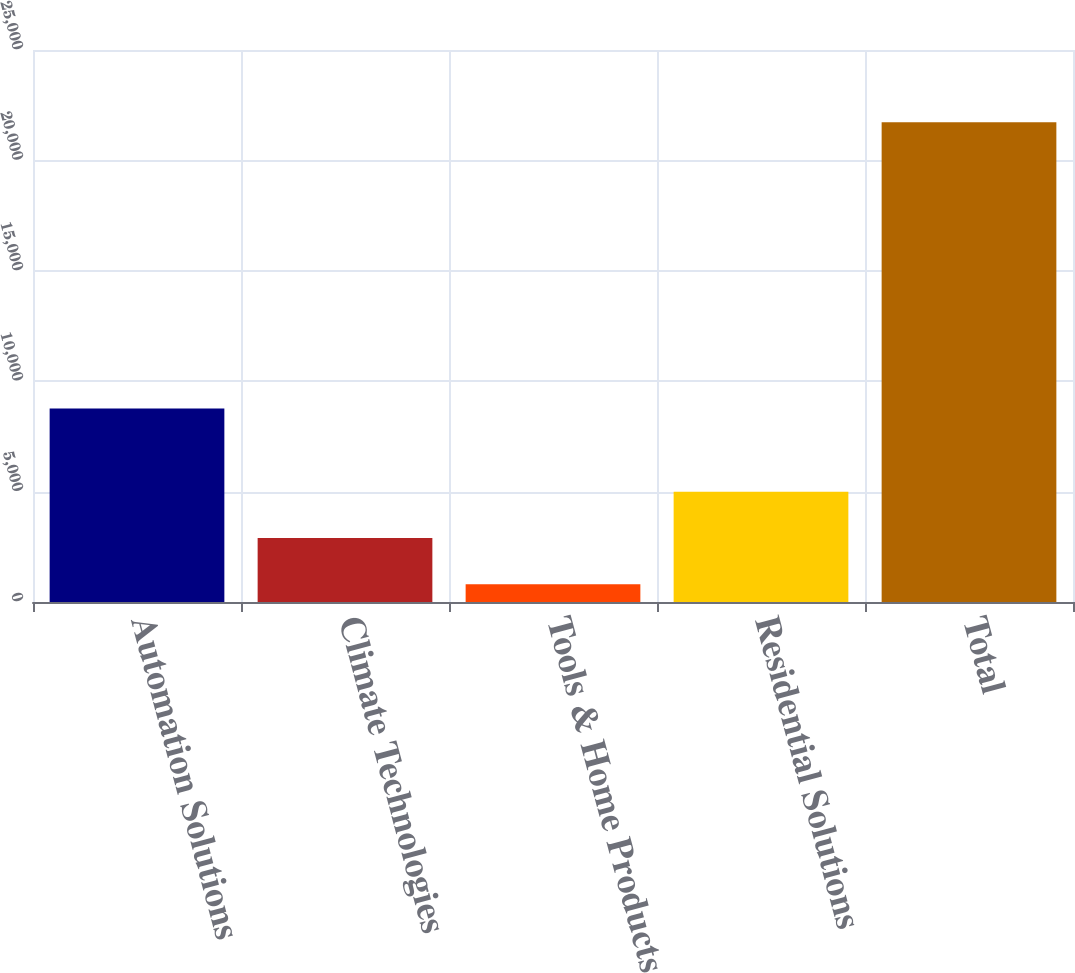Convert chart. <chart><loc_0><loc_0><loc_500><loc_500><bar_chart><fcel>Automation Solutions<fcel>Climate Technologies<fcel>Tools & Home Products<fcel>Residential Solutions<fcel>Total<nl><fcel>8759<fcel>2901.3<fcel>809<fcel>4993.6<fcel>21732<nl></chart> 